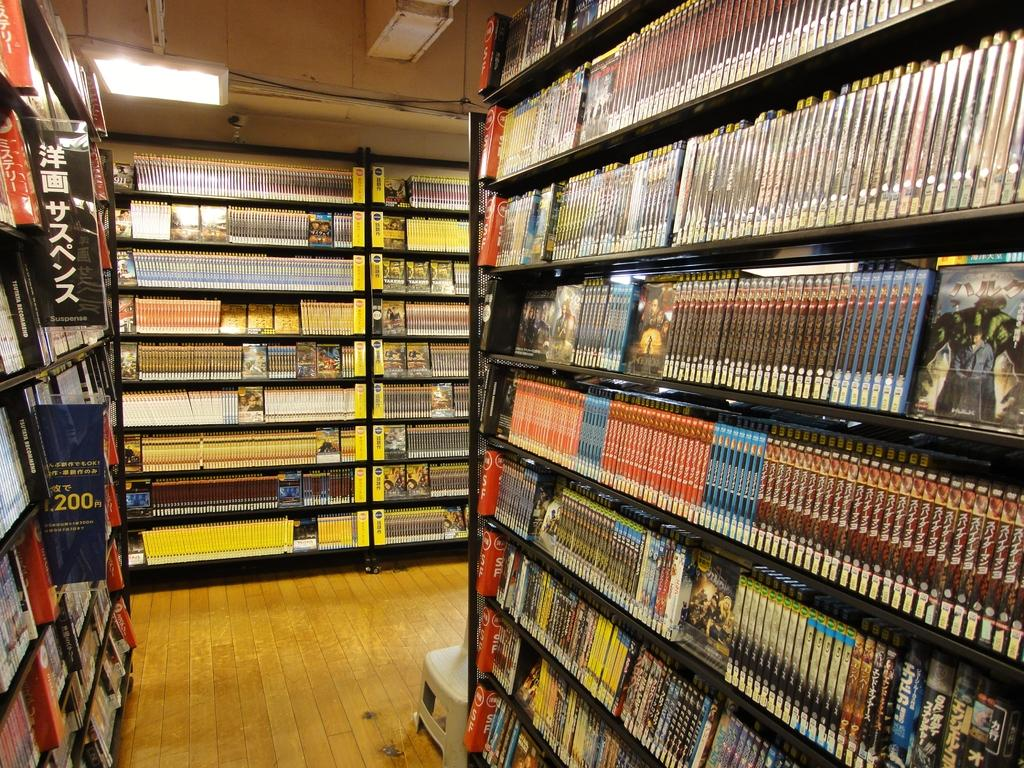What can be seen on either side of the image? There are many rocks on either side in the image. What is present on the wooden floor in the image? There are many books on the wooden floor in the image. What type of lighting is present in the image? There are lights over the ceiling in the image. Can you tell me how many thrills are present in the image? There is no mention of thrills in the image; it features rocks, books, and lights. Is there any wax visible in the image? There is no wax present in the image. 